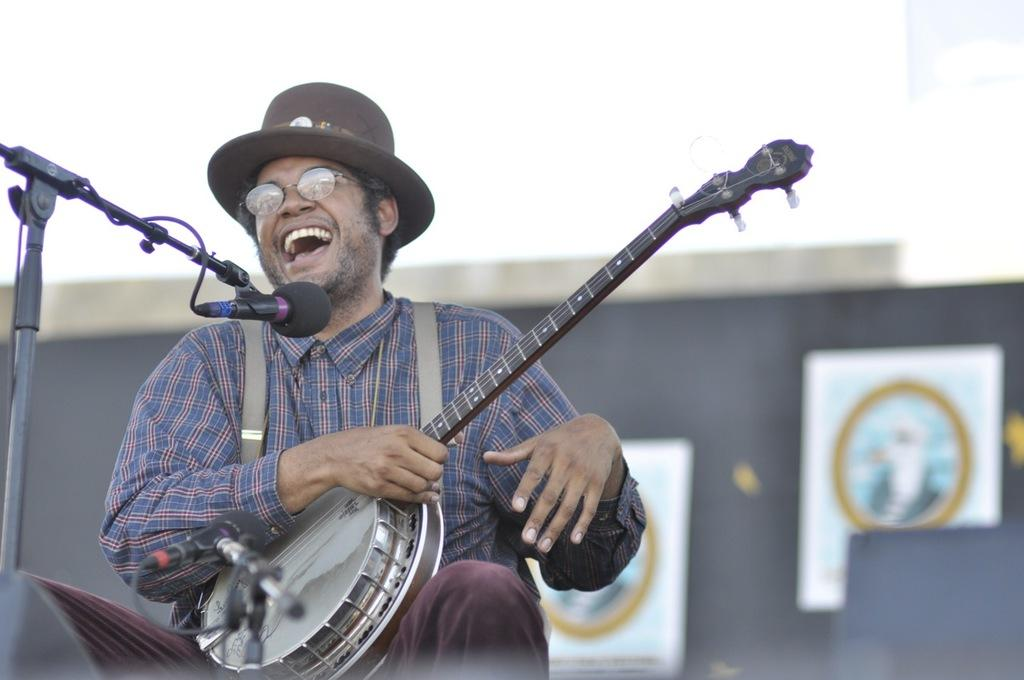What is the man in the image holding? The man is holding a musical instrument. Can you describe the man's appearance in the image? The man is wearing glasses (specs) and a hat. What is the purpose of the object on a stand in the image? The object on a stand is a microphone (mic). What can be seen on the wall in the background of the image? There are posters on the wall. How many birds are perched on the man's shoulder in the image? There are no birds present in the image. What color is the leaf on the man's hat in the image? The man is wearing a hat, but there is no mention of a leaf on it in the provided facts. 